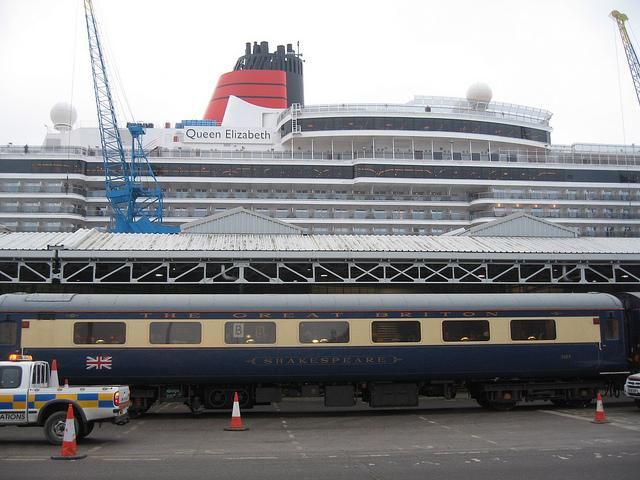The person whose name appears at the top is a descendant of whom?

Choices:
A) atahualpa
B) henry viii
C) saladin
D) temujin henry viii 